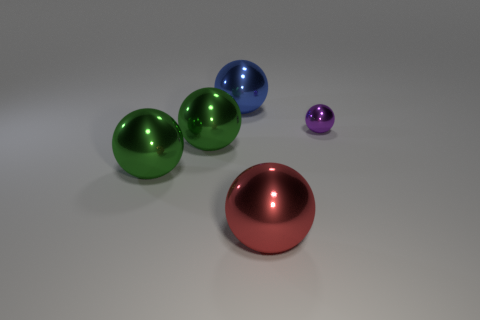There is a metal thing right of the red metal object; is its color the same as the large sphere that is to the right of the blue metallic object?
Offer a very short reply. No. Is the number of large red balls behind the blue sphere the same as the number of green things on the right side of the big red shiny object?
Offer a very short reply. Yes. What material is the big thing to the right of the sphere behind the tiny metallic object?
Offer a very short reply. Metal. How many objects are either large green shiny spheres or large red metal balls?
Ensure brevity in your answer.  3. Is the number of tiny yellow metal cylinders less than the number of purple balls?
Provide a short and direct response. Yes. What is the size of the other red sphere that is the same material as the tiny ball?
Your answer should be compact. Large. What is the size of the purple shiny thing?
Give a very brief answer. Small. There is a big blue object; what shape is it?
Provide a short and direct response. Sphere. Do the big thing that is on the right side of the big blue thing and the tiny ball have the same color?
Provide a short and direct response. No. What size is the red thing that is the same shape as the big blue thing?
Offer a very short reply. Large. 